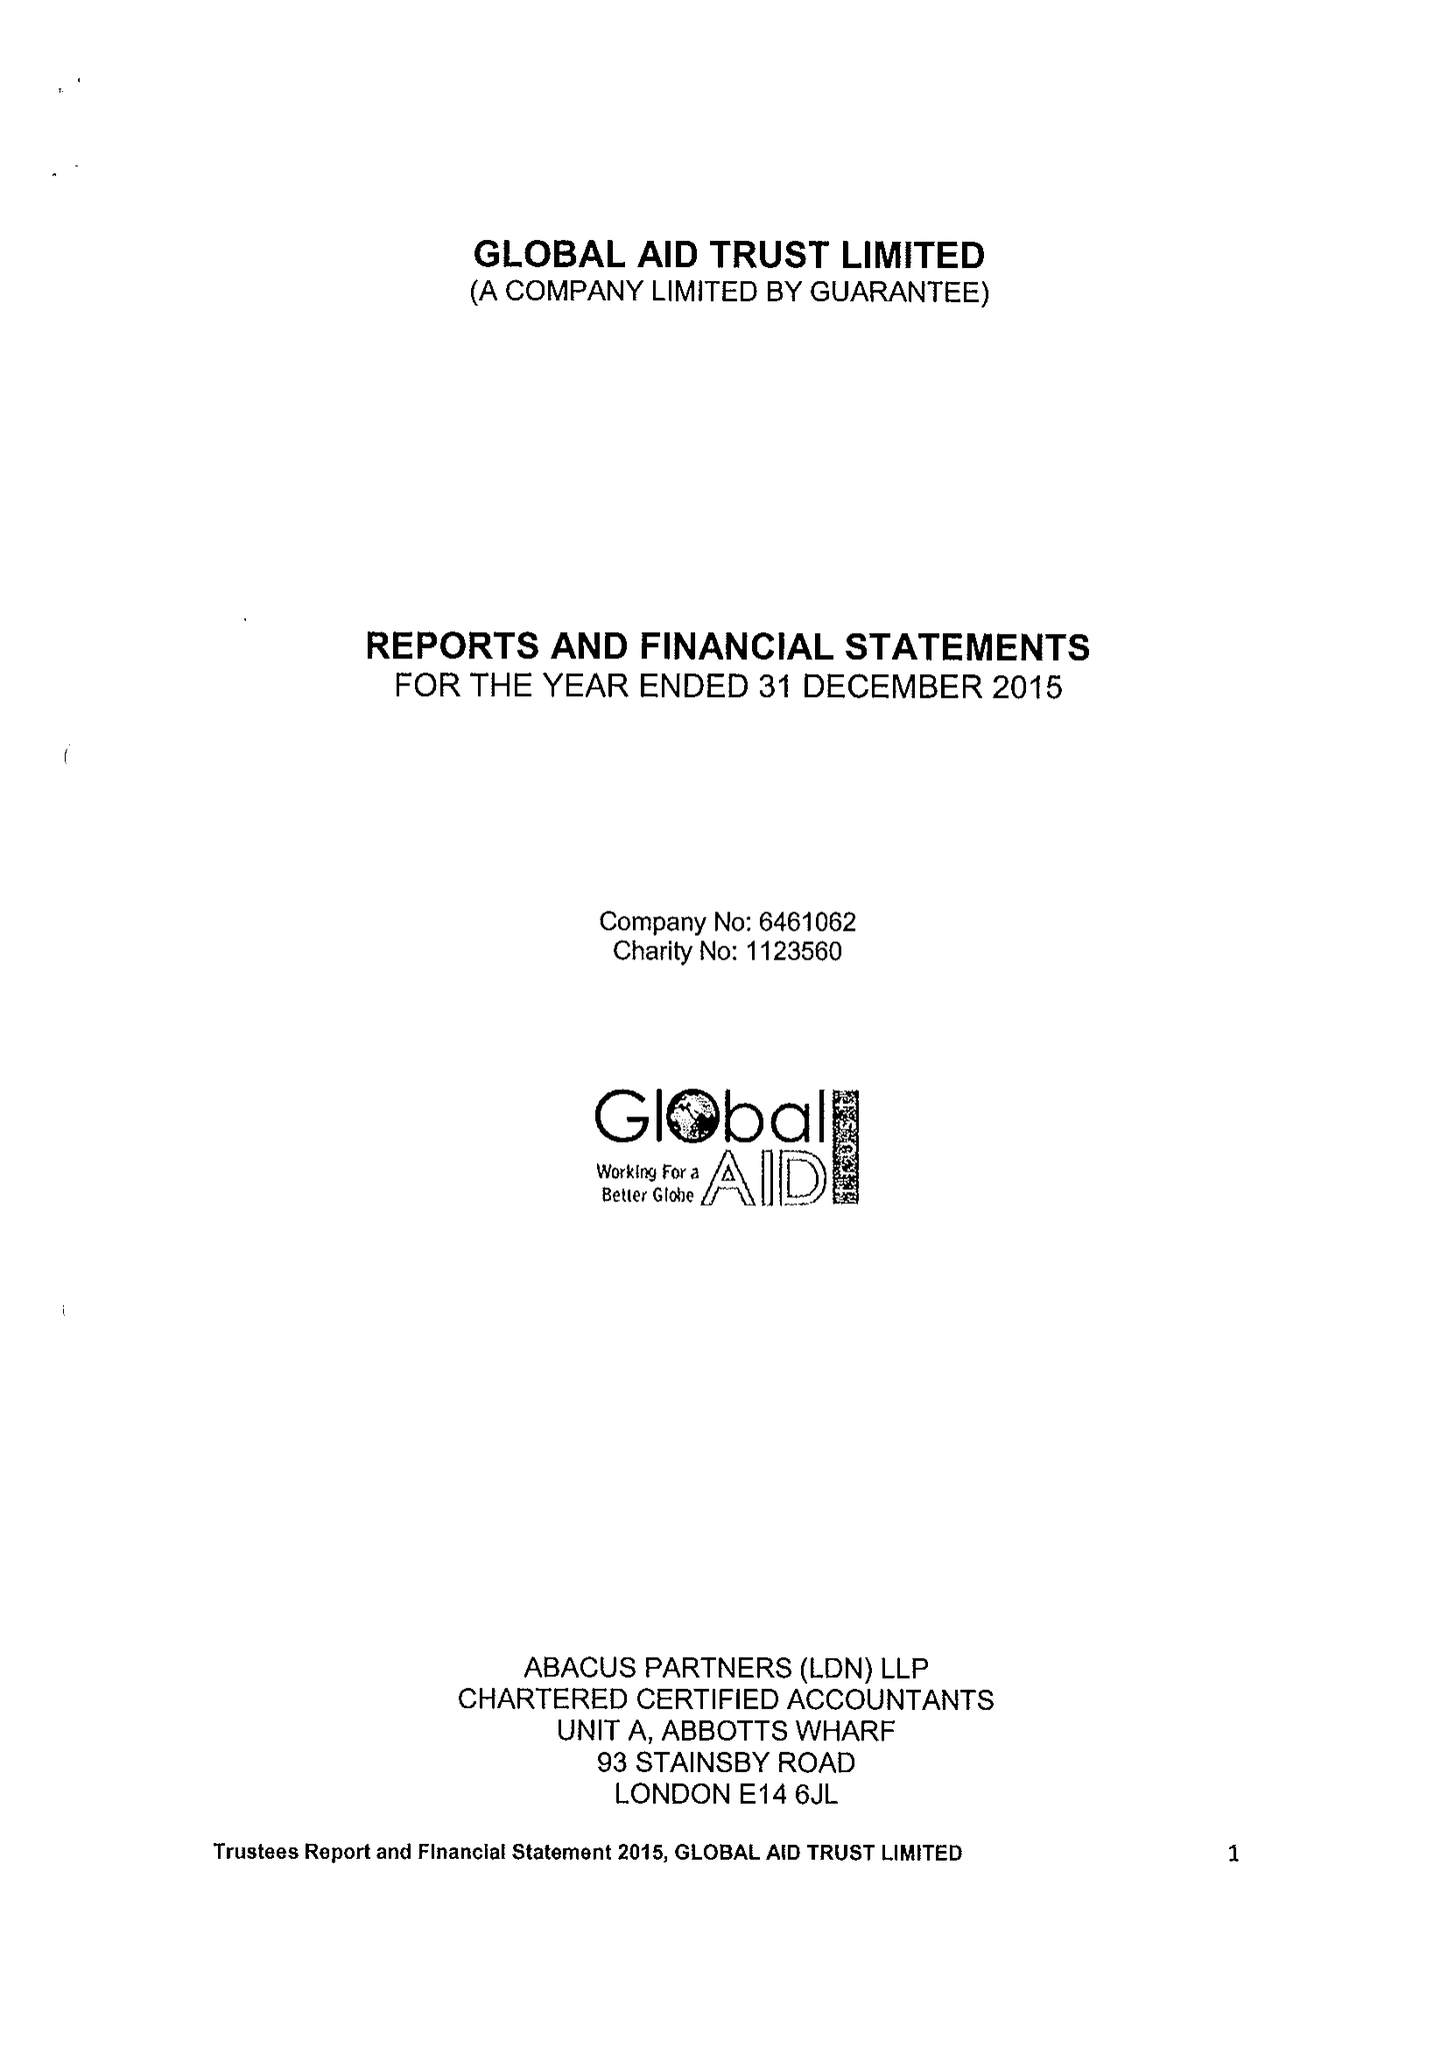What is the value for the charity_number?
Answer the question using a single word or phrase. 1123560 